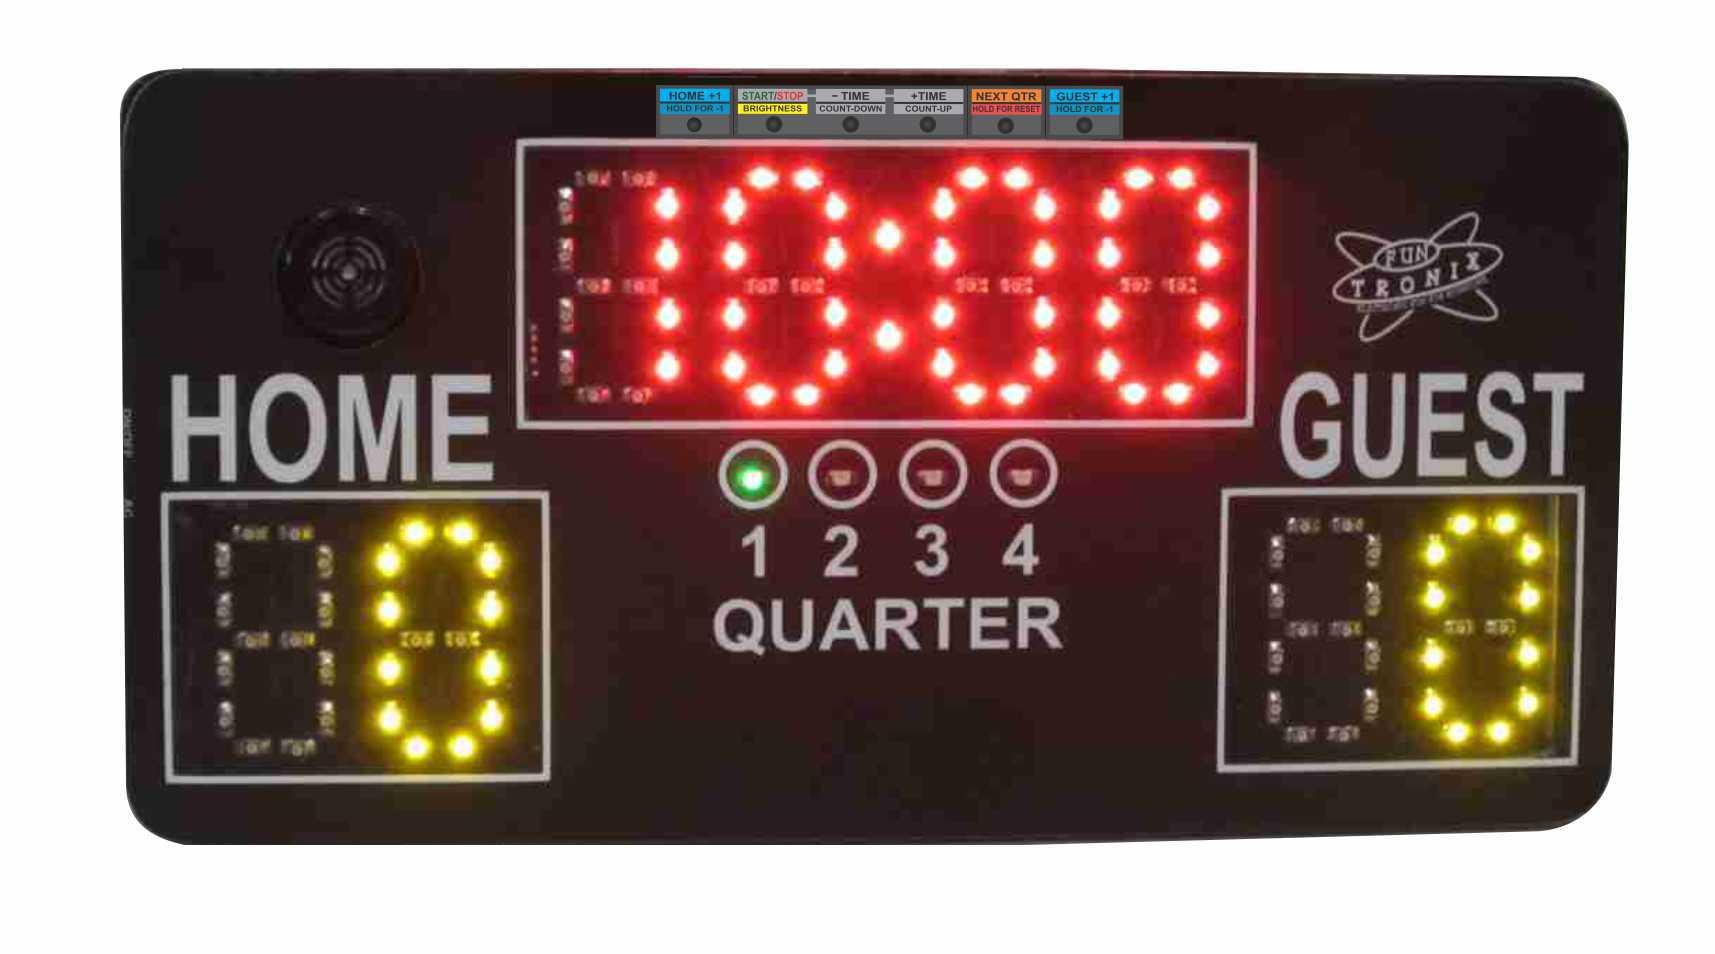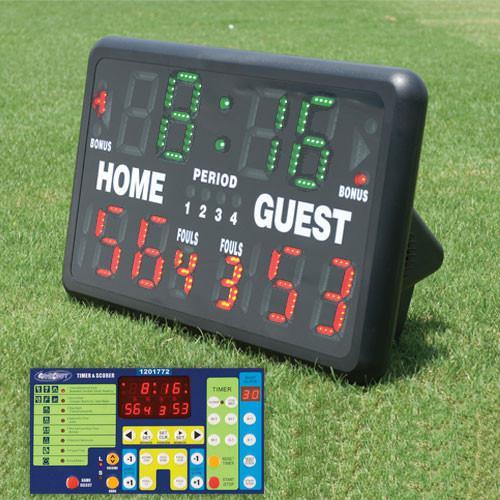The first image is the image on the left, the second image is the image on the right. Assess this claim about the two images: "There are two scoreboards which list the home score on the left side and the guest score on the right side.". Correct or not? Answer yes or no. Yes. 